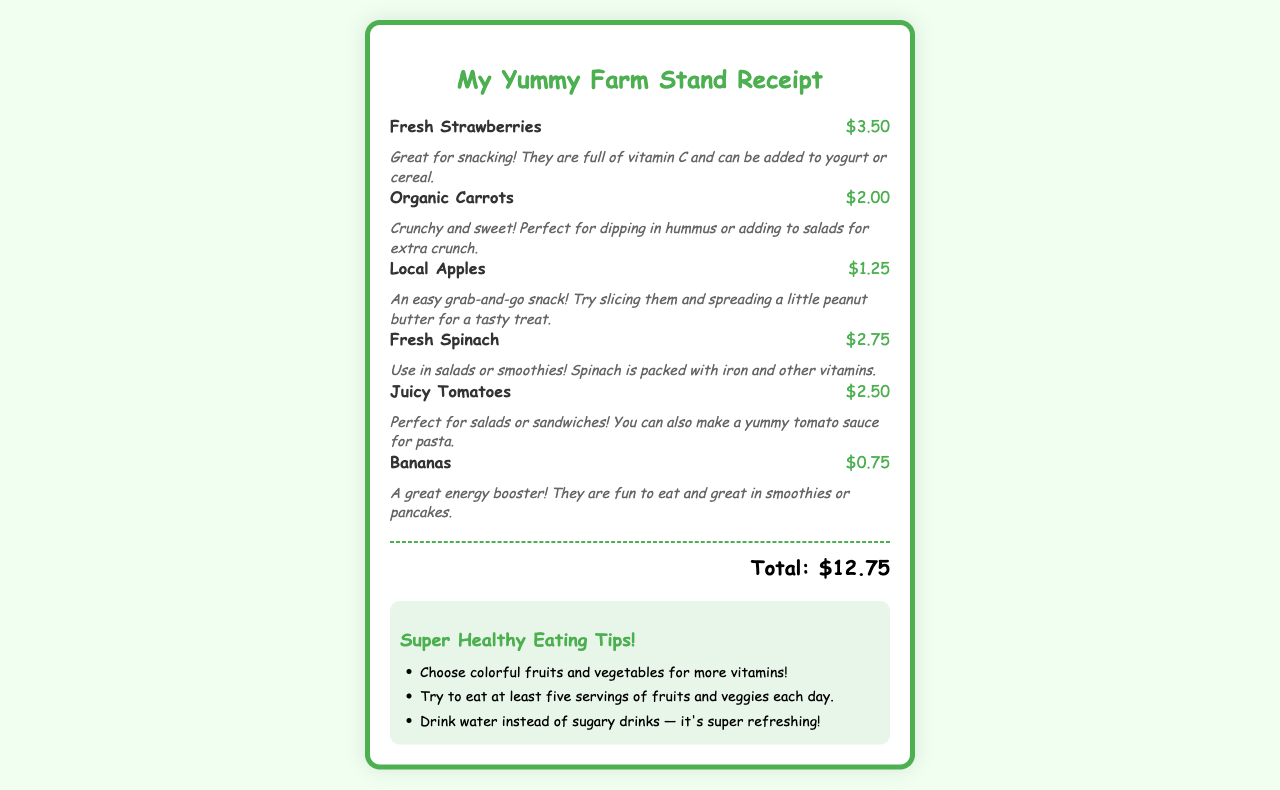What is the total amount on the receipt? The total amount is displayed at the bottom of the receipt indicating the cost of all items purchased.
Answer: $12.75 How much do fresh strawberries cost? The price of fresh strawberries is listed on the receipt next to the item name.
Answer: $3.50 What type of carrots are listed? The receipt specifies the variety of carrots purchased, which is noted next to the price.
Answer: Organic Which item costs the least? The prices of all items are compared to find the one with the lowest cost.
Answer: $0.75 What can you dip organic carrots in? The suggested use for organic carrots is mentioned in the tip below the item description.
Answer: Hummus What fruit is recommended for spreading peanut butter? The receipt provides a tip that describes how to enjoy a specific fruit as a snack.
Answer: Apples How many servings of fruits and veggies should you aim to eat each day? The healthy eating tips section includes advice on daily consumption recommendations.
Answer: Five What vitamin are strawberries high in? The item tip for strawberries mentions a specific vitamin they are rich in.
Answer: Vitamin C What color fruits and veggies are suggested for more vitamins? The tips encourage choosing fruits and vegetables based on their appearance for health benefits.
Answer: Colorful 